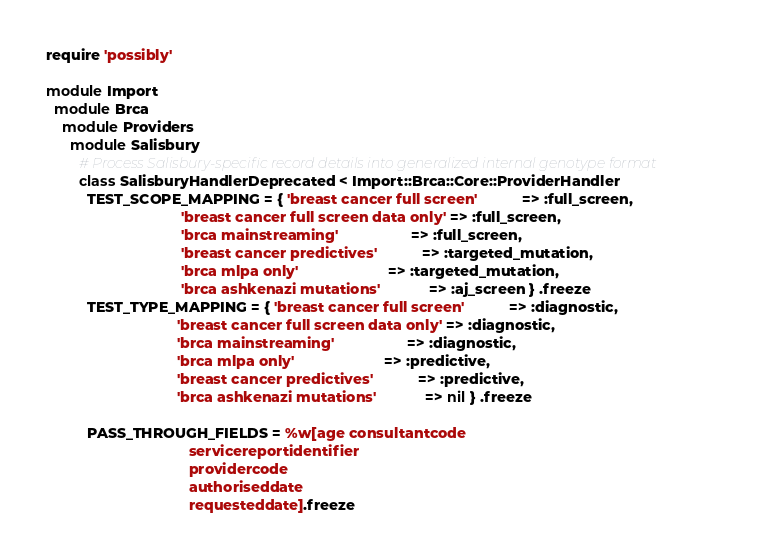<code> <loc_0><loc_0><loc_500><loc_500><_Ruby_>require 'possibly'

module Import
  module Brca
    module Providers
      module Salisbury
        # Process Salisbury-specific record details into generalized internal genotype format
        class SalisburyHandlerDeprecated < Import::Brca::Core::ProviderHandler
          TEST_SCOPE_MAPPING = { 'breast cancer full screen'           => :full_screen,
                                 'breast cancer full screen data only' => :full_screen,
                                 'brca mainstreaming'                  => :full_screen,
                                 'breast cancer predictives'           => :targeted_mutation,
                                 'brca mlpa only'                      => :targeted_mutation,
                                 'brca ashkenazi mutations'            => :aj_screen } .freeze
          TEST_TYPE_MAPPING = { 'breast cancer full screen'           => :diagnostic,
                                'breast cancer full screen data only' => :diagnostic,
                                'brca mainstreaming'                  => :diagnostic,
                                'brca mlpa only'                      => :predictive,
                                'breast cancer predictives'           => :predictive,
                                'brca ashkenazi mutations'            => nil } .freeze

          PASS_THROUGH_FIELDS = %w[age consultantcode
                                   servicereportidentifier
                                   providercode
                                   authoriseddate
                                   requesteddate].freeze
</code> 